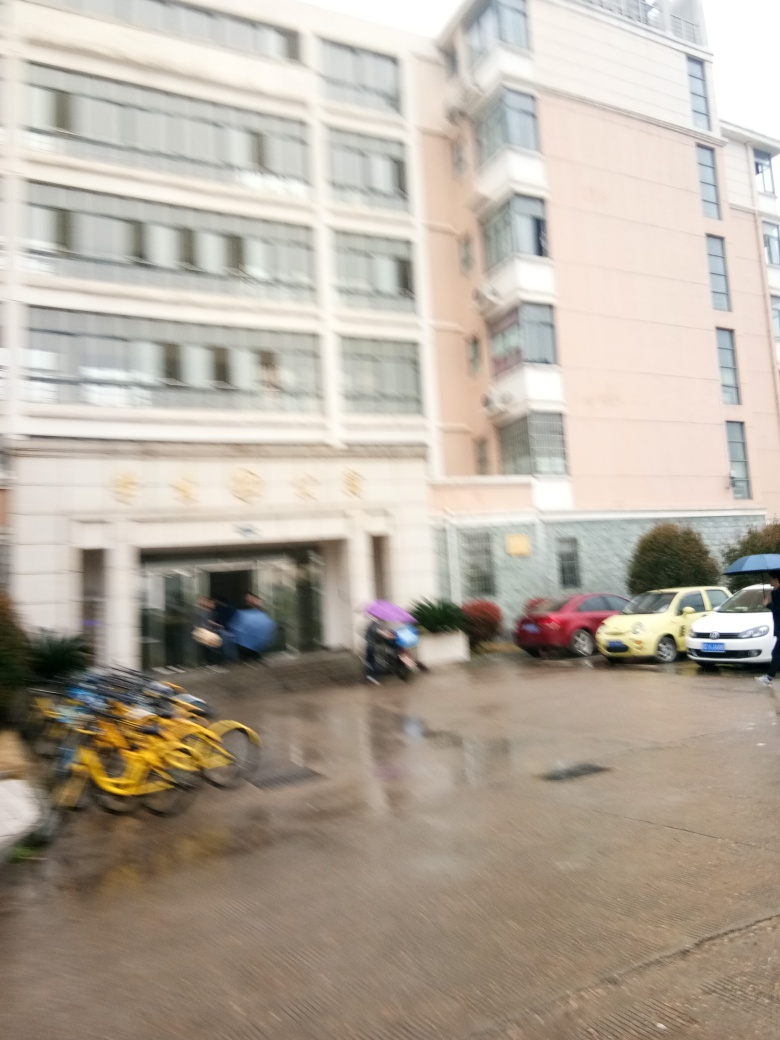Is this image intentionally blurred for artistic effect, or is it due to an error in capturing the photograph? Given the context and nature of the blurriness, the lack of focus appears to be accidental, possibly due to camera movement or incorrect focus settings at the time the photo was taken rather than an intentional artistic choice. 